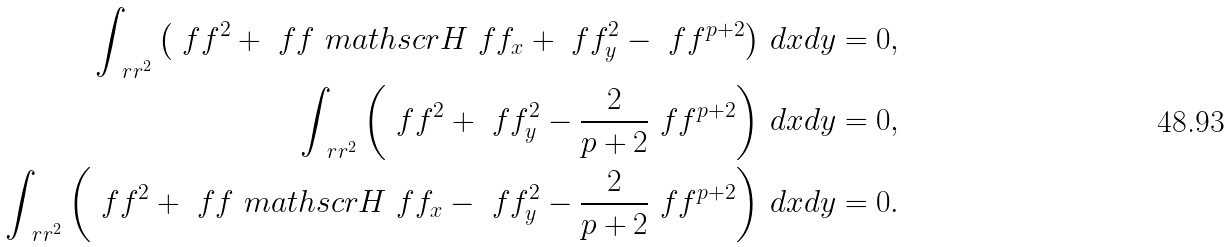<formula> <loc_0><loc_0><loc_500><loc_500>\int _ { \ r r ^ { 2 } } \left ( \ f f ^ { 2 } + \ f f \ m a t h s c r { H } \ f f _ { x } + \ f f _ { y } ^ { 2 } - \ f f ^ { p + 2 } \right ) \, d x d y = 0 , \\ \int _ { \ r r ^ { 2 } } \left ( \ f f ^ { 2 } + \ f f _ { y } ^ { 2 } - \frac { 2 } { p + 2 } \ f f ^ { p + 2 } \right ) \, d x d y = 0 , \\ \int _ { \ r r ^ { 2 } } \left ( \ f f ^ { 2 } + \ f f \ m a t h s c r { H } \ f f _ { x } - \ f f _ { y } ^ { 2 } - \frac { 2 } { p + 2 } \ f f ^ { p + 2 } \right ) \, d x d y = 0 .</formula> 